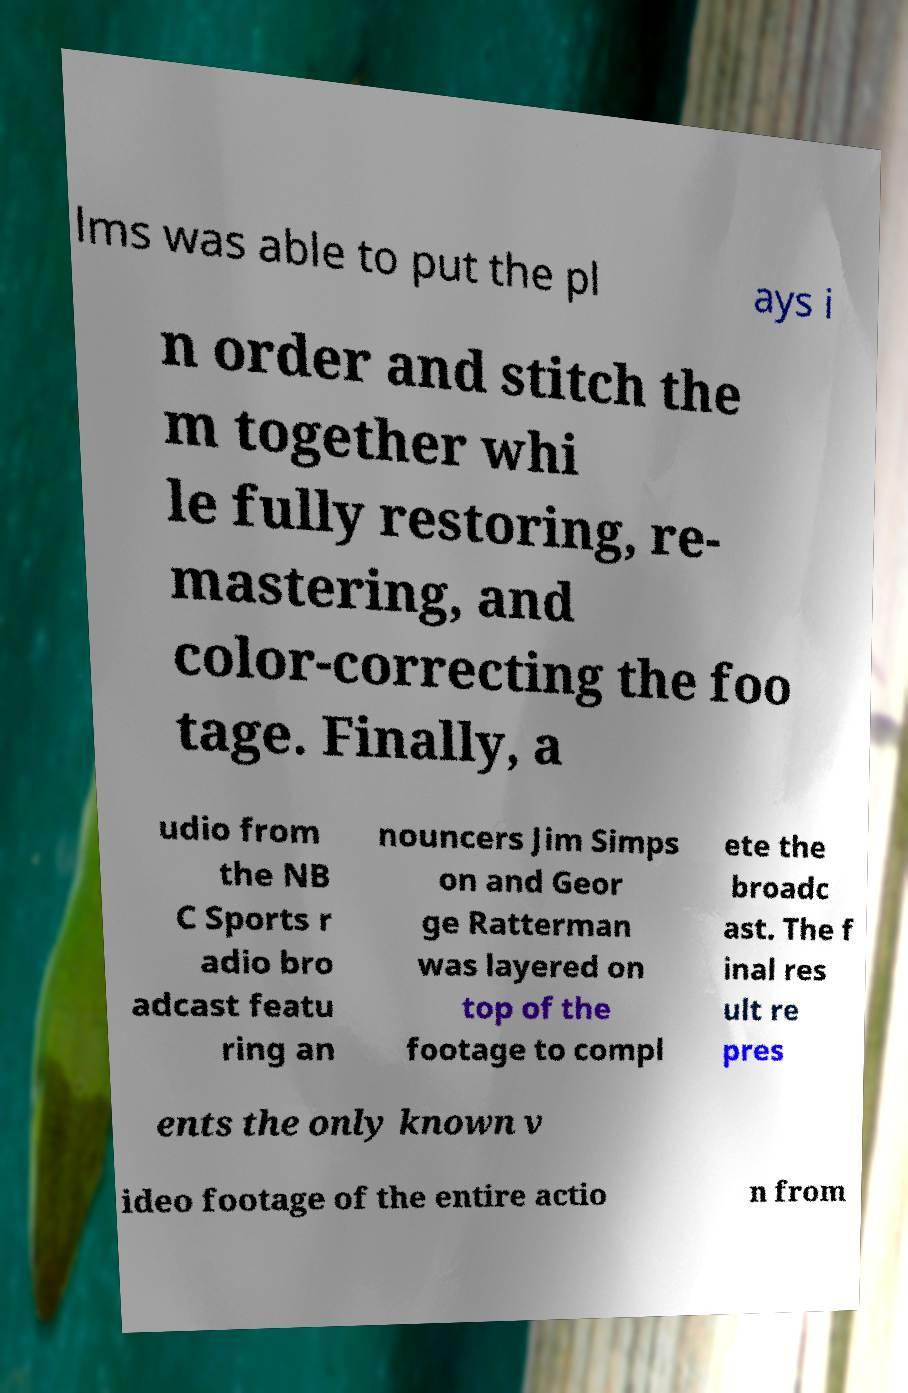Could you extract and type out the text from this image? lms was able to put the pl ays i n order and stitch the m together whi le fully restoring, re- mastering, and color-correcting the foo tage. Finally, a udio from the NB C Sports r adio bro adcast featu ring an nouncers Jim Simps on and Geor ge Ratterman was layered on top of the footage to compl ete the broadc ast. The f inal res ult re pres ents the only known v ideo footage of the entire actio n from 